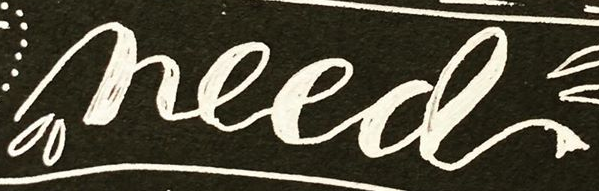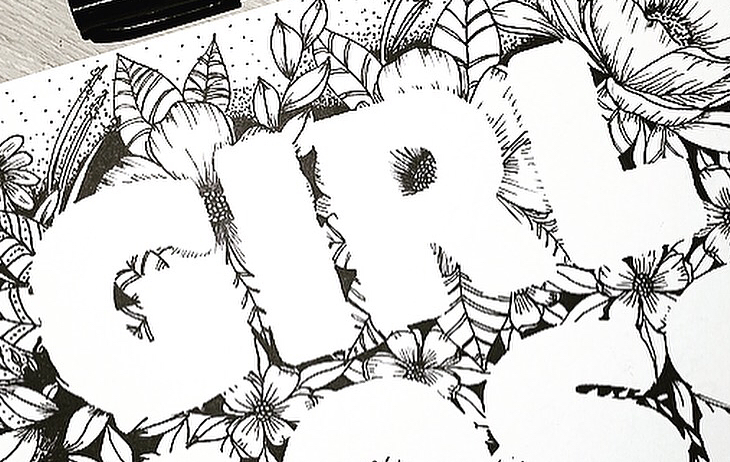What words can you see in these images in sequence, separated by a semicolon? need; GIRL 